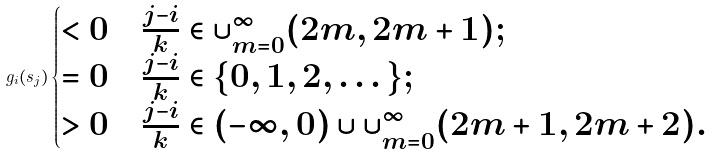<formula> <loc_0><loc_0><loc_500><loc_500>g _ { i } ( s _ { j } ) \begin{cases} < 0 & \frac { j - i } k \in \cup _ { m = 0 } ^ { \infty } ( 2 m , 2 m + 1 ) ; \\ = 0 & \frac { j - i } k \in \{ 0 , 1 , 2 , \dots \} ; \\ > 0 & \frac { j - i } k \in ( - \infty , 0 ) \cup \cup _ { m = 0 } ^ { \infty } ( 2 m + 1 , 2 m + 2 ) . \end{cases}</formula> 